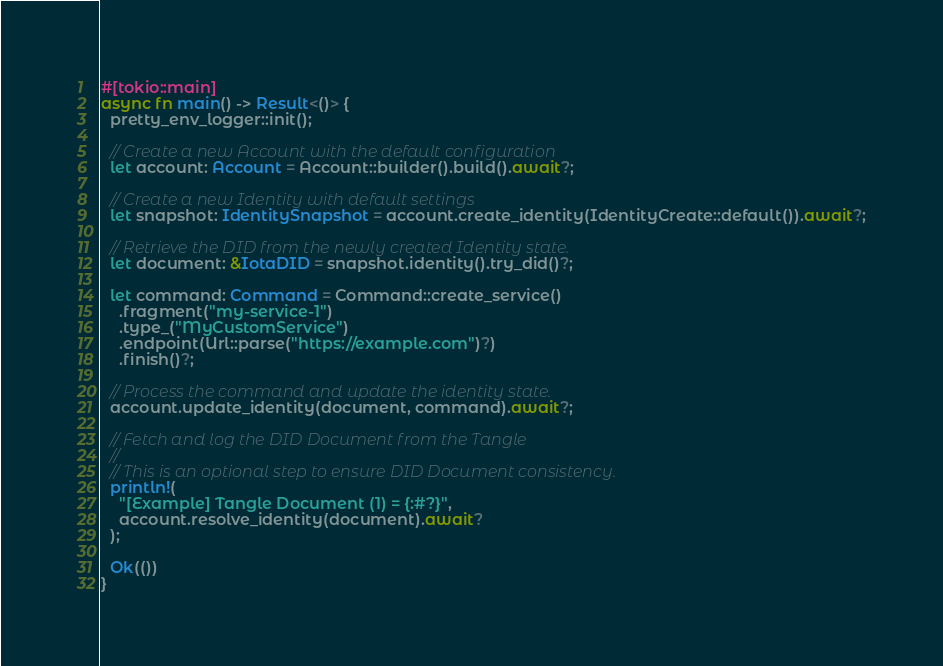<code> <loc_0><loc_0><loc_500><loc_500><_Rust_>
#[tokio::main]
async fn main() -> Result<()> {
  pretty_env_logger::init();

  // Create a new Account with the default configuration
  let account: Account = Account::builder().build().await?;

  // Create a new Identity with default settings
  let snapshot: IdentitySnapshot = account.create_identity(IdentityCreate::default()).await?;

  // Retrieve the DID from the newly created Identity state.
  let document: &IotaDID = snapshot.identity().try_did()?;

  let command: Command = Command::create_service()
    .fragment("my-service-1")
    .type_("MyCustomService")
    .endpoint(Url::parse("https://example.com")?)
    .finish()?;

  // Process the command and update the identity state.
  account.update_identity(document, command).await?;

  // Fetch and log the DID Document from the Tangle
  //
  // This is an optional step to ensure DID Document consistency.
  println!(
    "[Example] Tangle Document (1) = {:#?}",
    account.resolve_identity(document).await?
  );

  Ok(())
}
</code> 